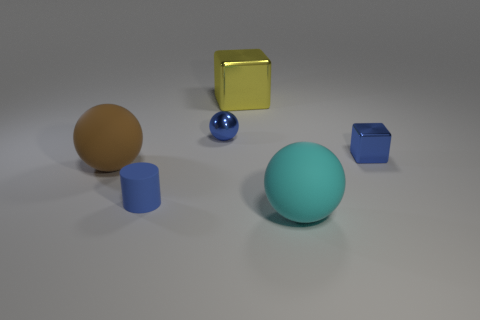Subtract all tiny shiny balls. How many balls are left? 2 Add 2 large cyan shiny cylinders. How many objects exist? 8 Subtract all cylinders. How many objects are left? 5 Subtract all red spheres. Subtract all gray cubes. How many spheres are left? 3 Subtract 0 purple cylinders. How many objects are left? 6 Subtract all tiny green matte spheres. Subtract all blue metal balls. How many objects are left? 5 Add 4 tiny blue matte cylinders. How many tiny blue matte cylinders are left? 5 Add 2 blue metal things. How many blue metal things exist? 4 